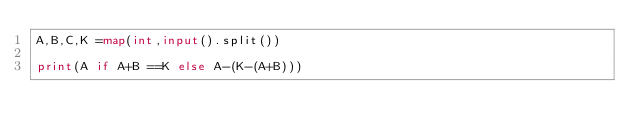Convert code to text. <code><loc_0><loc_0><loc_500><loc_500><_Python_>A,B,C,K =map(int,input().split())

print(A if A+B ==K else A-(K-(A+B)))</code> 